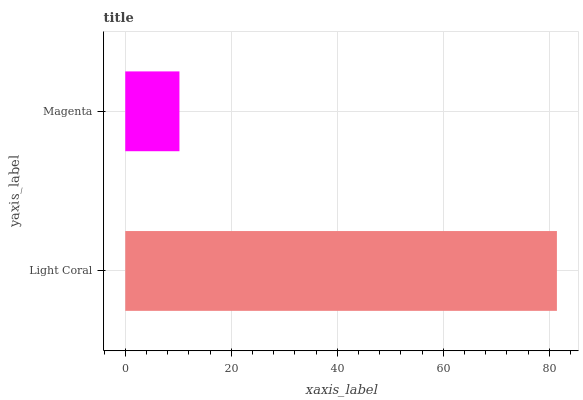Is Magenta the minimum?
Answer yes or no. Yes. Is Light Coral the maximum?
Answer yes or no. Yes. Is Magenta the maximum?
Answer yes or no. No. Is Light Coral greater than Magenta?
Answer yes or no. Yes. Is Magenta less than Light Coral?
Answer yes or no. Yes. Is Magenta greater than Light Coral?
Answer yes or no. No. Is Light Coral less than Magenta?
Answer yes or no. No. Is Light Coral the high median?
Answer yes or no. Yes. Is Magenta the low median?
Answer yes or no. Yes. Is Magenta the high median?
Answer yes or no. No. Is Light Coral the low median?
Answer yes or no. No. 